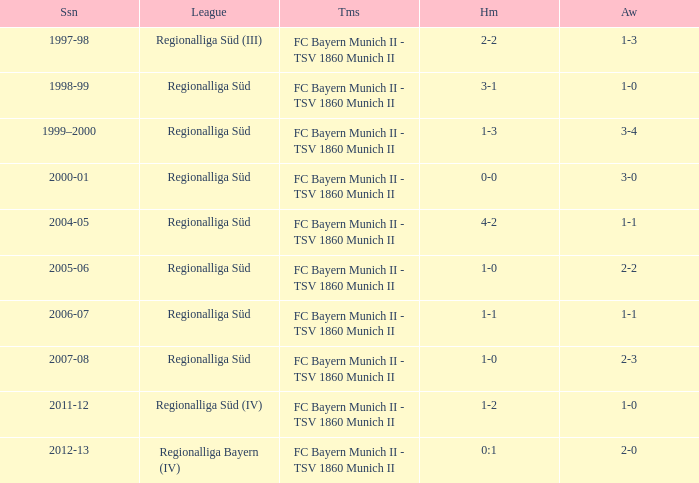What league has a 3-1 home? Regionalliga Süd. 